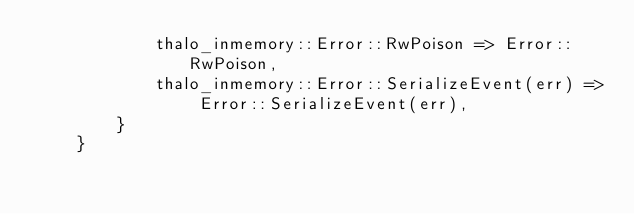Convert code to text. <code><loc_0><loc_0><loc_500><loc_500><_Rust_>            thalo_inmemory::Error::RwPoison => Error::RwPoison,
            thalo_inmemory::Error::SerializeEvent(err) => Error::SerializeEvent(err),
        }
    }</code> 